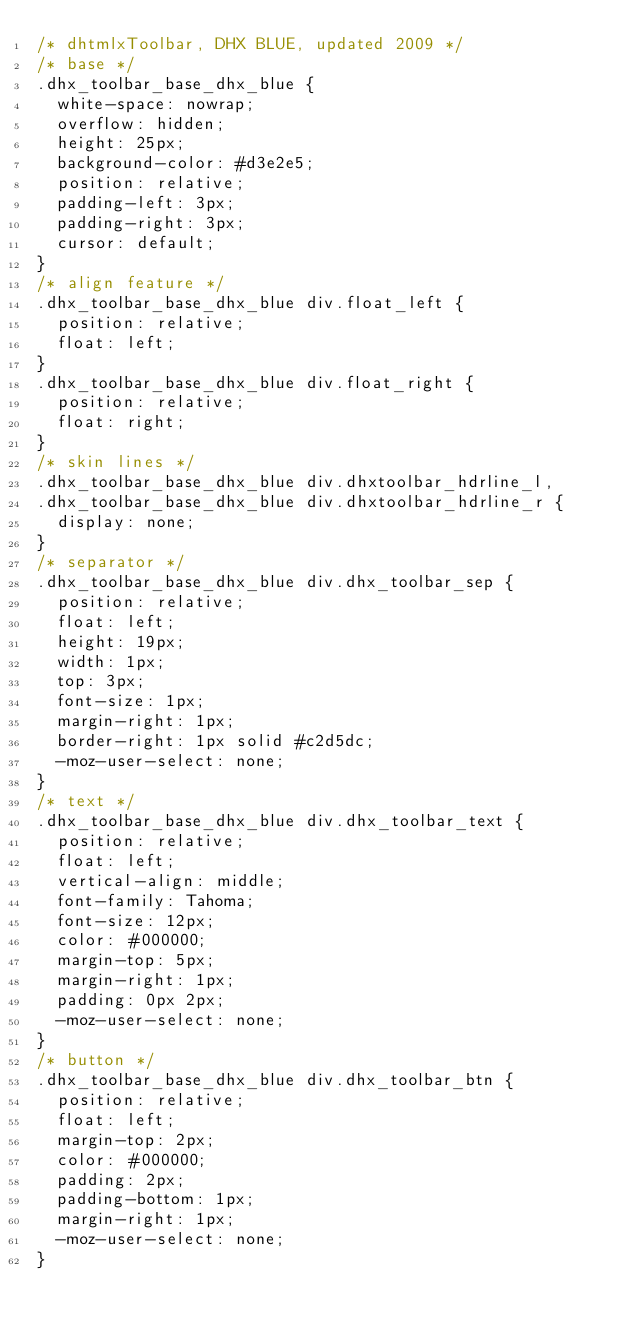<code> <loc_0><loc_0><loc_500><loc_500><_CSS_>/* dhtmlxToolbar, DHX BLUE, updated 2009 */
/* base */
.dhx_toolbar_base_dhx_blue {
	white-space: nowrap;
	overflow: hidden;
	height: 25px;
	background-color: #d3e2e5;
	position: relative;
	padding-left: 3px;
	padding-right: 3px;
	cursor: default;
}
/* align feature */
.dhx_toolbar_base_dhx_blue div.float_left {
	position: relative;
	float: left;
}
.dhx_toolbar_base_dhx_blue div.float_right {
	position: relative;
	float: right;
}
/* skin lines */
.dhx_toolbar_base_dhx_blue div.dhxtoolbar_hdrline_l,
.dhx_toolbar_base_dhx_blue div.dhxtoolbar_hdrline_r {
	display: none;
}
/* separator */
.dhx_toolbar_base_dhx_blue div.dhx_toolbar_sep {
	position: relative;
	float: left;
	height: 19px;
	width: 1px;
	top: 3px;
	font-size: 1px;
	margin-right: 1px;
	border-right: 1px solid #c2d5dc;
	-moz-user-select: none;
}
/* text */
.dhx_toolbar_base_dhx_blue div.dhx_toolbar_text {
	position: relative;
	float: left;
	vertical-align: middle;
	font-family: Tahoma;
	font-size: 12px;
	color: #000000;
	margin-top: 5px;
	margin-right: 1px;
	padding: 0px 2px;
	-moz-user-select: none;
}
/* button */
.dhx_toolbar_base_dhx_blue div.dhx_toolbar_btn {
	position: relative;
	float: left;
	margin-top: 2px;
	color: #000000;
	padding: 2px;
	padding-bottom: 1px;
	margin-right: 1px;
	-moz-user-select: none;
}</code> 